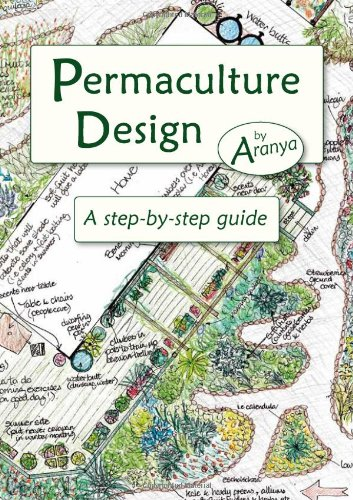Could this book be useful for someone with no prior knowledge of permaculture? Absolutely, 'Permaculture Design: A Step-by-Step Guide' is particularly designed for beginners. It provides a structured, easy-to-follow approach that educates readers on the basics of permaculture and how to apply them. 